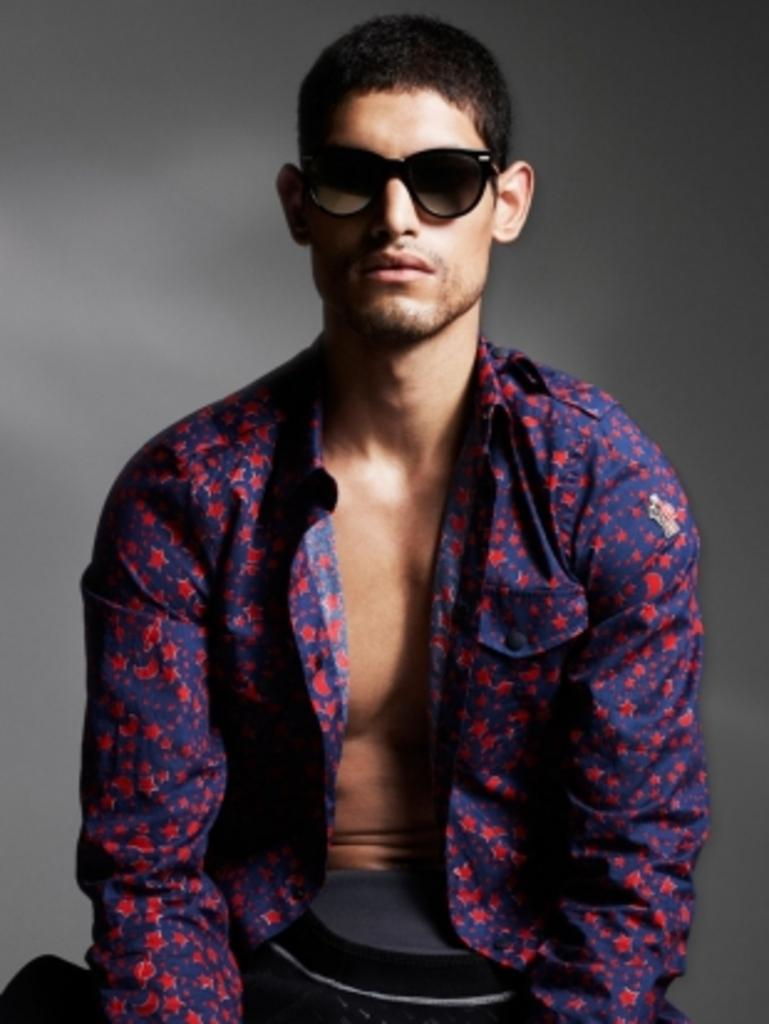Who is present in the image? There is a man in the image. What is the man wearing on his upper body? The man is wearing a purple shirt. What type of eyewear is the man wearing? The man is wearing black color spectacles. What is the color of the background in the image? The background of the image is in grey color. What type of police art can be seen in the image? There is no police art present in the image; it features a man wearing a purple shirt and black spectacles against a grey background. What kind of rock formation is visible in the image? There is no rock formation visible in the image; it is a close-up of a man wearing a purple shirt and black spectacles against a grey background. 